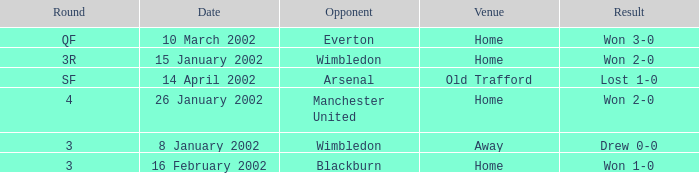What is the Date with a Opponent with wimbledon, and a Result of won 2-0? 15 January 2002. 